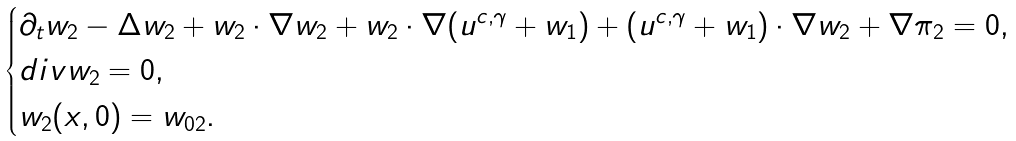Convert formula to latex. <formula><loc_0><loc_0><loc_500><loc_500>\begin{cases} \partial _ { t } w _ { 2 } - \Delta w _ { 2 } + w _ { 2 } \cdot \nabla w _ { 2 } + w _ { 2 } \cdot \nabla ( u ^ { c , \gamma } + w _ { 1 } ) + ( u ^ { c , \gamma } + w _ { 1 } ) \cdot \nabla w _ { 2 } + \nabla \pi _ { 2 } = 0 , \\ d i v w _ { 2 } = 0 , \\ w _ { 2 } ( x , 0 ) = w _ { 0 2 } . \end{cases}</formula> 